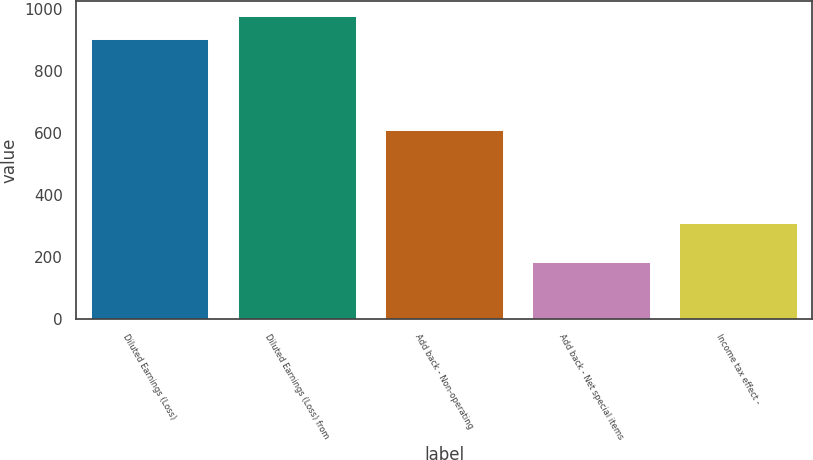<chart> <loc_0><loc_0><loc_500><loc_500><bar_chart><fcel>Diluted Earnings (Loss)<fcel>Diluted Earnings (Loss) from<fcel>Add back - Non-operating<fcel>Add back - Net special items<fcel>Income tax effect -<nl><fcel>904<fcel>976.7<fcel>610<fcel>182<fcel>309<nl></chart> 